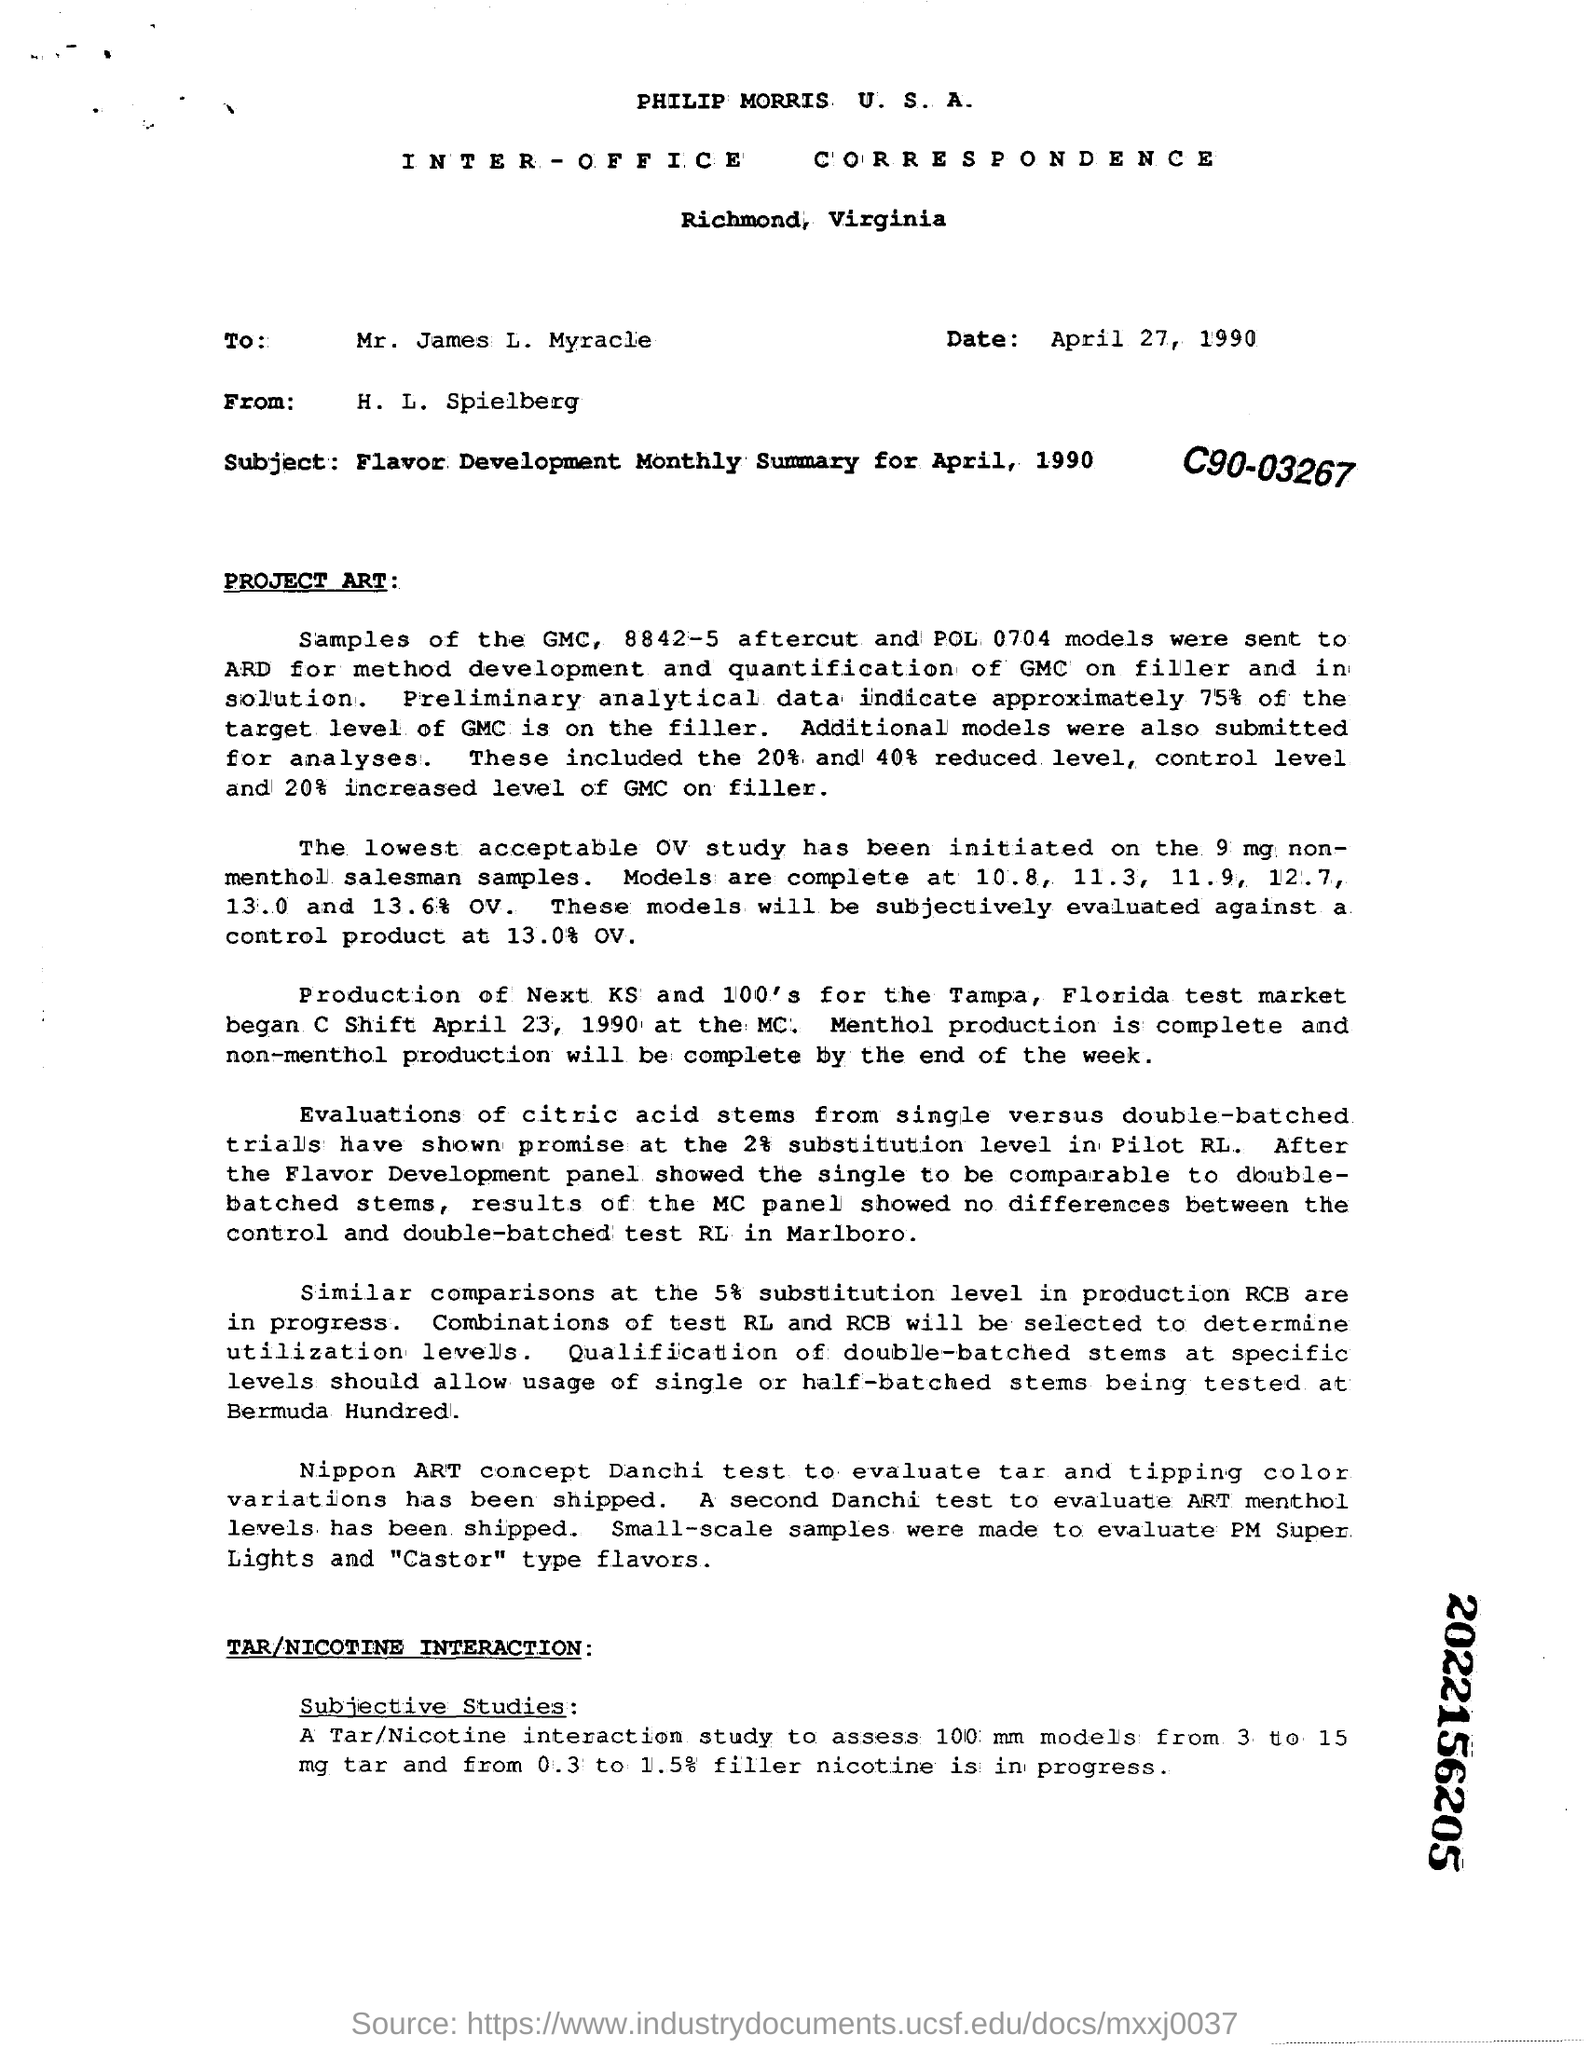Indicate a few pertinent items in this graphic. This is an inter-office communication/letter. A second Dandachi Test is used to evaluate menthol levels in ART that has been shipped. The date mentioned in the letter is April 27, 1990. The subject of the document/letter is the "Flavor Development Monthly Summary for April, 1990. 